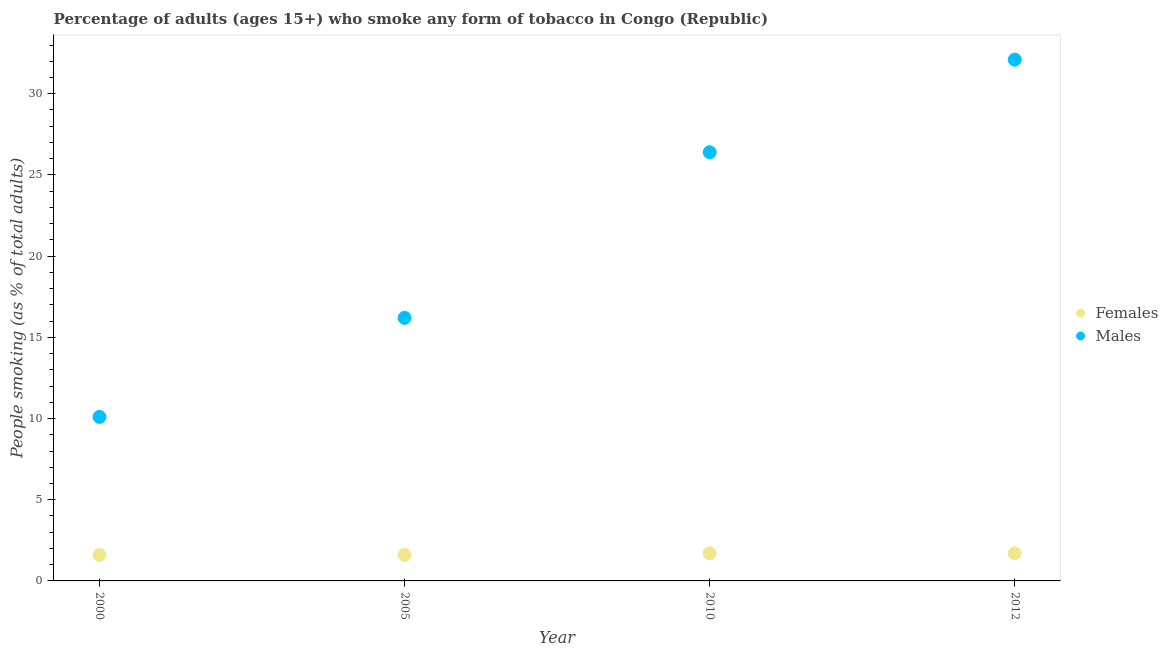How many different coloured dotlines are there?
Provide a succinct answer. 2. What is the percentage of males who smoke in 2005?
Offer a very short reply. 16.2. Across all years, what is the maximum percentage of females who smoke?
Ensure brevity in your answer.  1.7. Across all years, what is the minimum percentage of females who smoke?
Give a very brief answer. 1.6. In which year was the percentage of females who smoke maximum?
Give a very brief answer. 2010. What is the total percentage of males who smoke in the graph?
Your answer should be very brief. 84.8. What is the difference between the percentage of females who smoke in 2010 and the percentage of males who smoke in 2012?
Make the answer very short. -30.4. What is the average percentage of females who smoke per year?
Make the answer very short. 1.65. In the year 2010, what is the difference between the percentage of females who smoke and percentage of males who smoke?
Provide a succinct answer. -24.7. In how many years, is the percentage of females who smoke greater than 5 %?
Ensure brevity in your answer.  0. What is the ratio of the percentage of females who smoke in 2005 to that in 2012?
Your answer should be compact. 0.94. Is the percentage of males who smoke in 2000 less than that in 2010?
Offer a terse response. Yes. Is the difference between the percentage of males who smoke in 2000 and 2005 greater than the difference between the percentage of females who smoke in 2000 and 2005?
Provide a succinct answer. No. What is the difference between the highest and the second highest percentage of males who smoke?
Make the answer very short. 5.7. In how many years, is the percentage of males who smoke greater than the average percentage of males who smoke taken over all years?
Offer a terse response. 2. Is the sum of the percentage of males who smoke in 2000 and 2010 greater than the maximum percentage of females who smoke across all years?
Your answer should be very brief. Yes. Is the percentage of females who smoke strictly greater than the percentage of males who smoke over the years?
Your answer should be very brief. No. How many dotlines are there?
Offer a very short reply. 2. How many years are there in the graph?
Provide a short and direct response. 4. What is the difference between two consecutive major ticks on the Y-axis?
Keep it short and to the point. 5. Where does the legend appear in the graph?
Ensure brevity in your answer.  Center right. How are the legend labels stacked?
Make the answer very short. Vertical. What is the title of the graph?
Give a very brief answer. Percentage of adults (ages 15+) who smoke any form of tobacco in Congo (Republic). What is the label or title of the Y-axis?
Offer a very short reply. People smoking (as % of total adults). What is the People smoking (as % of total adults) in Males in 2000?
Your answer should be compact. 10.1. What is the People smoking (as % of total adults) in Females in 2005?
Provide a succinct answer. 1.6. What is the People smoking (as % of total adults) in Males in 2010?
Your answer should be very brief. 26.4. What is the People smoking (as % of total adults) of Females in 2012?
Your response must be concise. 1.7. What is the People smoking (as % of total adults) of Males in 2012?
Give a very brief answer. 32.1. Across all years, what is the maximum People smoking (as % of total adults) in Males?
Give a very brief answer. 32.1. Across all years, what is the minimum People smoking (as % of total adults) in Females?
Keep it short and to the point. 1.6. Across all years, what is the minimum People smoking (as % of total adults) in Males?
Your answer should be compact. 10.1. What is the total People smoking (as % of total adults) in Females in the graph?
Keep it short and to the point. 6.6. What is the total People smoking (as % of total adults) in Males in the graph?
Make the answer very short. 84.8. What is the difference between the People smoking (as % of total adults) in Males in 2000 and that in 2005?
Your answer should be very brief. -6.1. What is the difference between the People smoking (as % of total adults) in Females in 2000 and that in 2010?
Offer a terse response. -0.1. What is the difference between the People smoking (as % of total adults) in Males in 2000 and that in 2010?
Provide a short and direct response. -16.3. What is the difference between the People smoking (as % of total adults) of Females in 2000 and that in 2012?
Your answer should be compact. -0.1. What is the difference between the People smoking (as % of total adults) of Males in 2005 and that in 2010?
Offer a terse response. -10.2. What is the difference between the People smoking (as % of total adults) of Females in 2005 and that in 2012?
Provide a short and direct response. -0.1. What is the difference between the People smoking (as % of total adults) in Males in 2005 and that in 2012?
Your response must be concise. -15.9. What is the difference between the People smoking (as % of total adults) of Females in 2010 and that in 2012?
Your response must be concise. 0. What is the difference between the People smoking (as % of total adults) in Males in 2010 and that in 2012?
Your answer should be very brief. -5.7. What is the difference between the People smoking (as % of total adults) of Females in 2000 and the People smoking (as % of total adults) of Males in 2005?
Provide a succinct answer. -14.6. What is the difference between the People smoking (as % of total adults) in Females in 2000 and the People smoking (as % of total adults) in Males in 2010?
Keep it short and to the point. -24.8. What is the difference between the People smoking (as % of total adults) of Females in 2000 and the People smoking (as % of total adults) of Males in 2012?
Provide a short and direct response. -30.5. What is the difference between the People smoking (as % of total adults) in Females in 2005 and the People smoking (as % of total adults) in Males in 2010?
Your answer should be very brief. -24.8. What is the difference between the People smoking (as % of total adults) in Females in 2005 and the People smoking (as % of total adults) in Males in 2012?
Give a very brief answer. -30.5. What is the difference between the People smoking (as % of total adults) in Females in 2010 and the People smoking (as % of total adults) in Males in 2012?
Your answer should be compact. -30.4. What is the average People smoking (as % of total adults) in Females per year?
Give a very brief answer. 1.65. What is the average People smoking (as % of total adults) in Males per year?
Your answer should be compact. 21.2. In the year 2005, what is the difference between the People smoking (as % of total adults) in Females and People smoking (as % of total adults) in Males?
Offer a terse response. -14.6. In the year 2010, what is the difference between the People smoking (as % of total adults) in Females and People smoking (as % of total adults) in Males?
Provide a short and direct response. -24.7. In the year 2012, what is the difference between the People smoking (as % of total adults) in Females and People smoking (as % of total adults) in Males?
Your answer should be compact. -30.4. What is the ratio of the People smoking (as % of total adults) in Females in 2000 to that in 2005?
Provide a short and direct response. 1. What is the ratio of the People smoking (as % of total adults) in Males in 2000 to that in 2005?
Ensure brevity in your answer.  0.62. What is the ratio of the People smoking (as % of total adults) in Males in 2000 to that in 2010?
Ensure brevity in your answer.  0.38. What is the ratio of the People smoking (as % of total adults) of Males in 2000 to that in 2012?
Your response must be concise. 0.31. What is the ratio of the People smoking (as % of total adults) of Females in 2005 to that in 2010?
Your answer should be very brief. 0.94. What is the ratio of the People smoking (as % of total adults) in Males in 2005 to that in 2010?
Give a very brief answer. 0.61. What is the ratio of the People smoking (as % of total adults) of Males in 2005 to that in 2012?
Make the answer very short. 0.5. What is the ratio of the People smoking (as % of total adults) of Females in 2010 to that in 2012?
Make the answer very short. 1. What is the ratio of the People smoking (as % of total adults) in Males in 2010 to that in 2012?
Offer a very short reply. 0.82. What is the difference between the highest and the lowest People smoking (as % of total adults) in Females?
Make the answer very short. 0.1. 